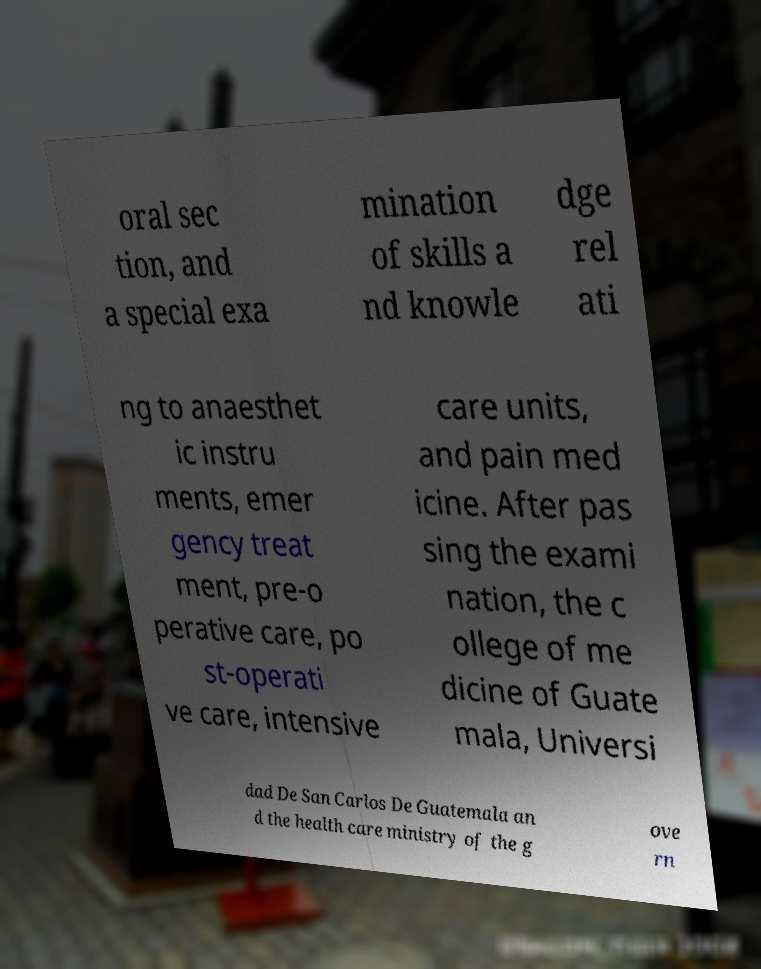What messages or text are displayed in this image? I need them in a readable, typed format. oral sec tion, and a special exa mination of skills a nd knowle dge rel ati ng to anaesthet ic instru ments, emer gency treat ment, pre-o perative care, po st-operati ve care, intensive care units, and pain med icine. After pas sing the exami nation, the c ollege of me dicine of Guate mala, Universi dad De San Carlos De Guatemala an d the health care ministry of the g ove rn 